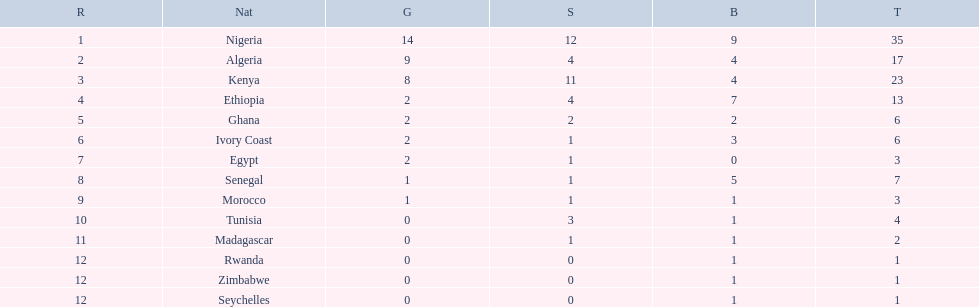Which country had the least bronze medals? Egypt. 